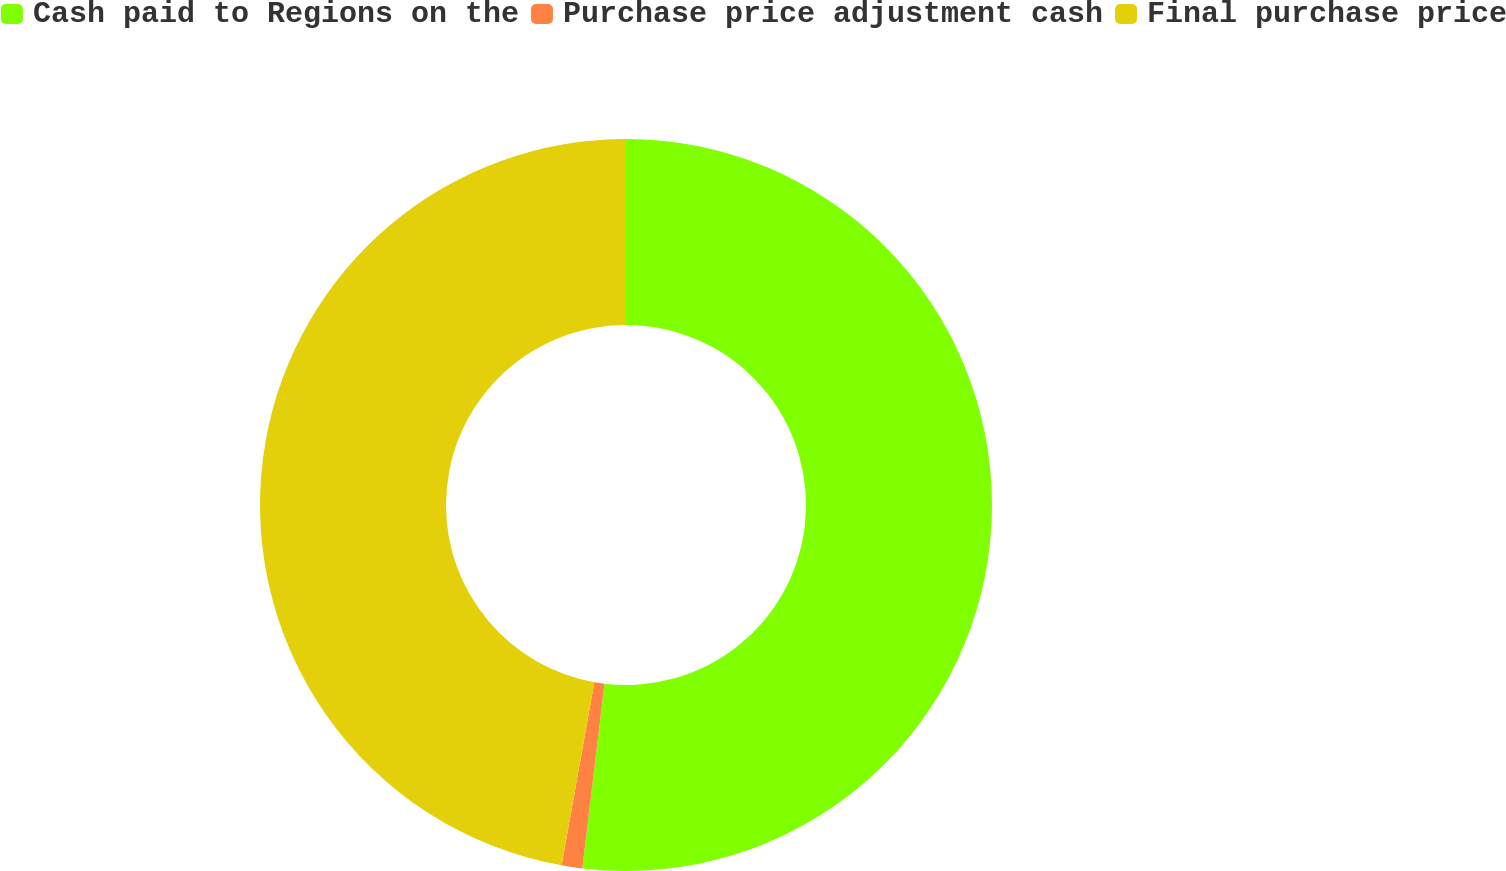<chart> <loc_0><loc_0><loc_500><loc_500><pie_chart><fcel>Cash paid to Regions on the<fcel>Purchase price adjustment cash<fcel>Final purchase price<nl><fcel>51.9%<fcel>0.91%<fcel>47.18%<nl></chart> 